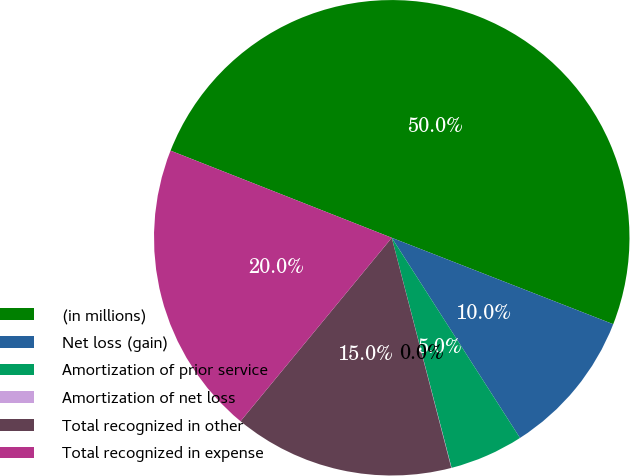Convert chart. <chart><loc_0><loc_0><loc_500><loc_500><pie_chart><fcel>(in millions)<fcel>Net loss (gain)<fcel>Amortization of prior service<fcel>Amortization of net loss<fcel>Total recognized in other<fcel>Total recognized in expense<nl><fcel>49.95%<fcel>10.01%<fcel>5.02%<fcel>0.02%<fcel>15.0%<fcel>20.0%<nl></chart> 